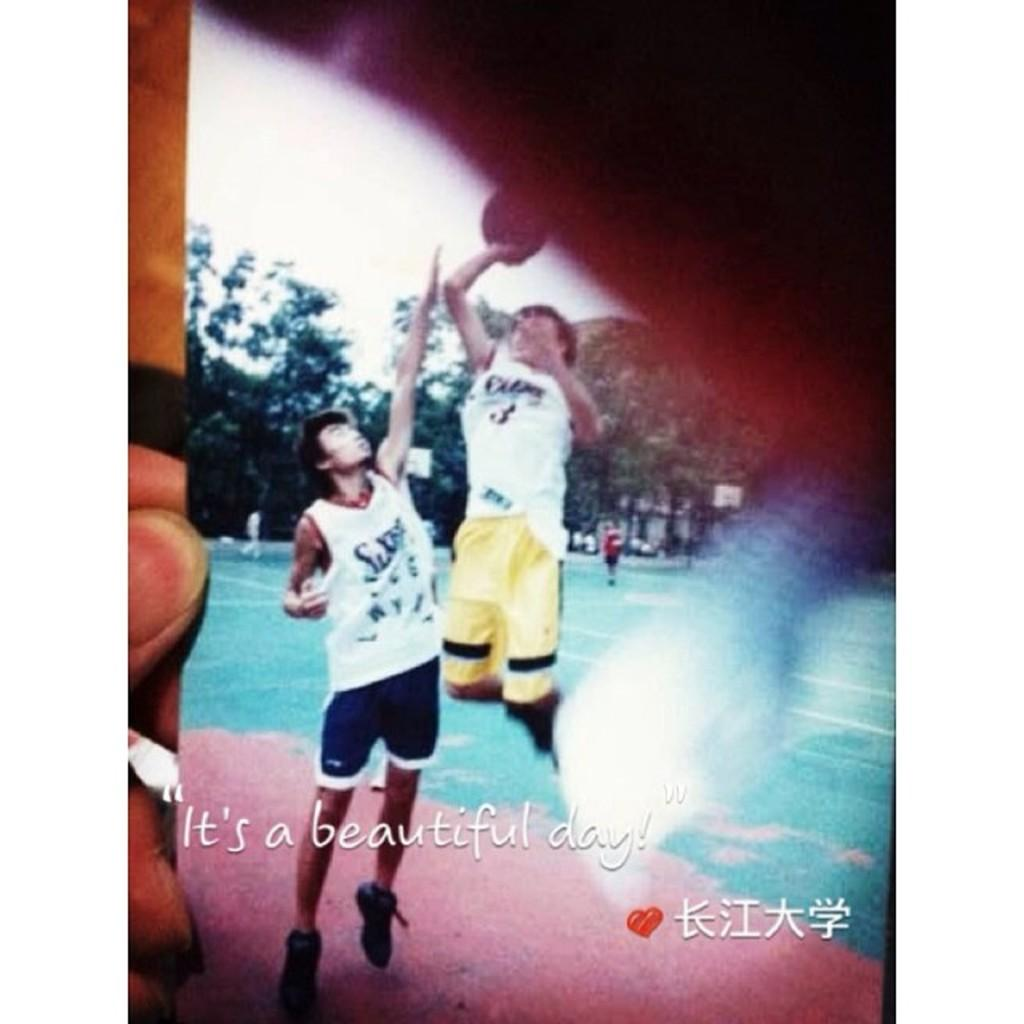What is the main subject of the image? The image contains a photograph. What can be seen in the photograph? The photograph includes people and trees. What part of the natural environment is visible in the photograph? The sky is visible in the photograph. What type of calendar is hanging on the tree in the photograph? There is no calendar present in the photograph; it features people and trees. What is the kettle used for in the photograph? There is no kettle present in the photograph. 